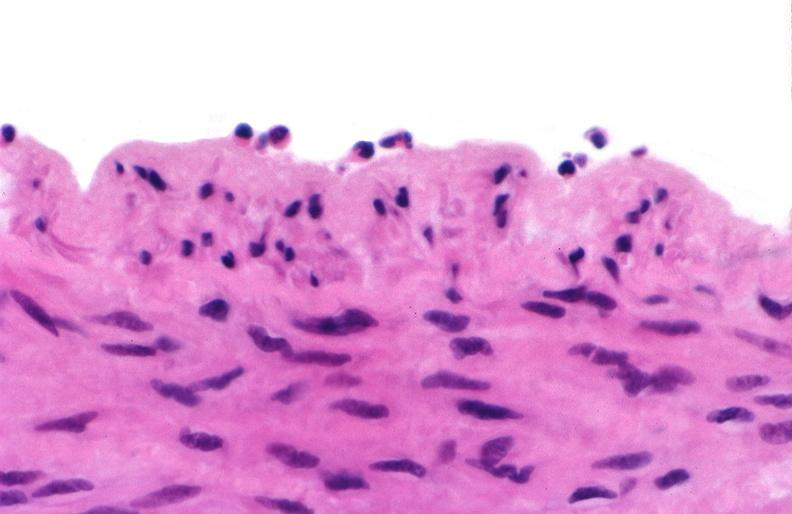where is this from?
Answer the question using a single word or phrase. Vasculature 